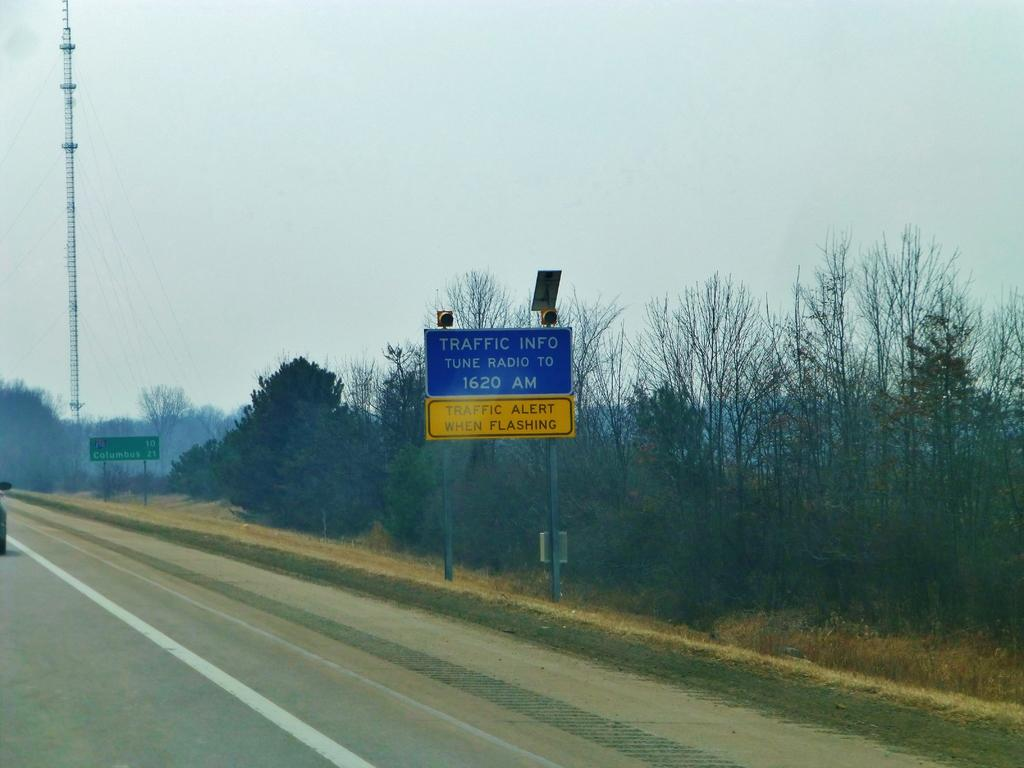What objects can be seen in the image that are made of wood or a similar material? There are boards in the image. What type of natural vegetation is present in the image? There are trees in the image. What is attached to the pole in the image? There is a pole with wires in the image. What type of transportation is visible on the road in the image? There is a vehicle on the road in the image. What is visible at the top of the image? The sky is visible at the top of the image. What type of fruit is hanging from the pole with wires in the image? There is no fruit hanging from the pole with wires in the image. Can you tell me how many knees are visible in the image? There are no knees visible in the image. 